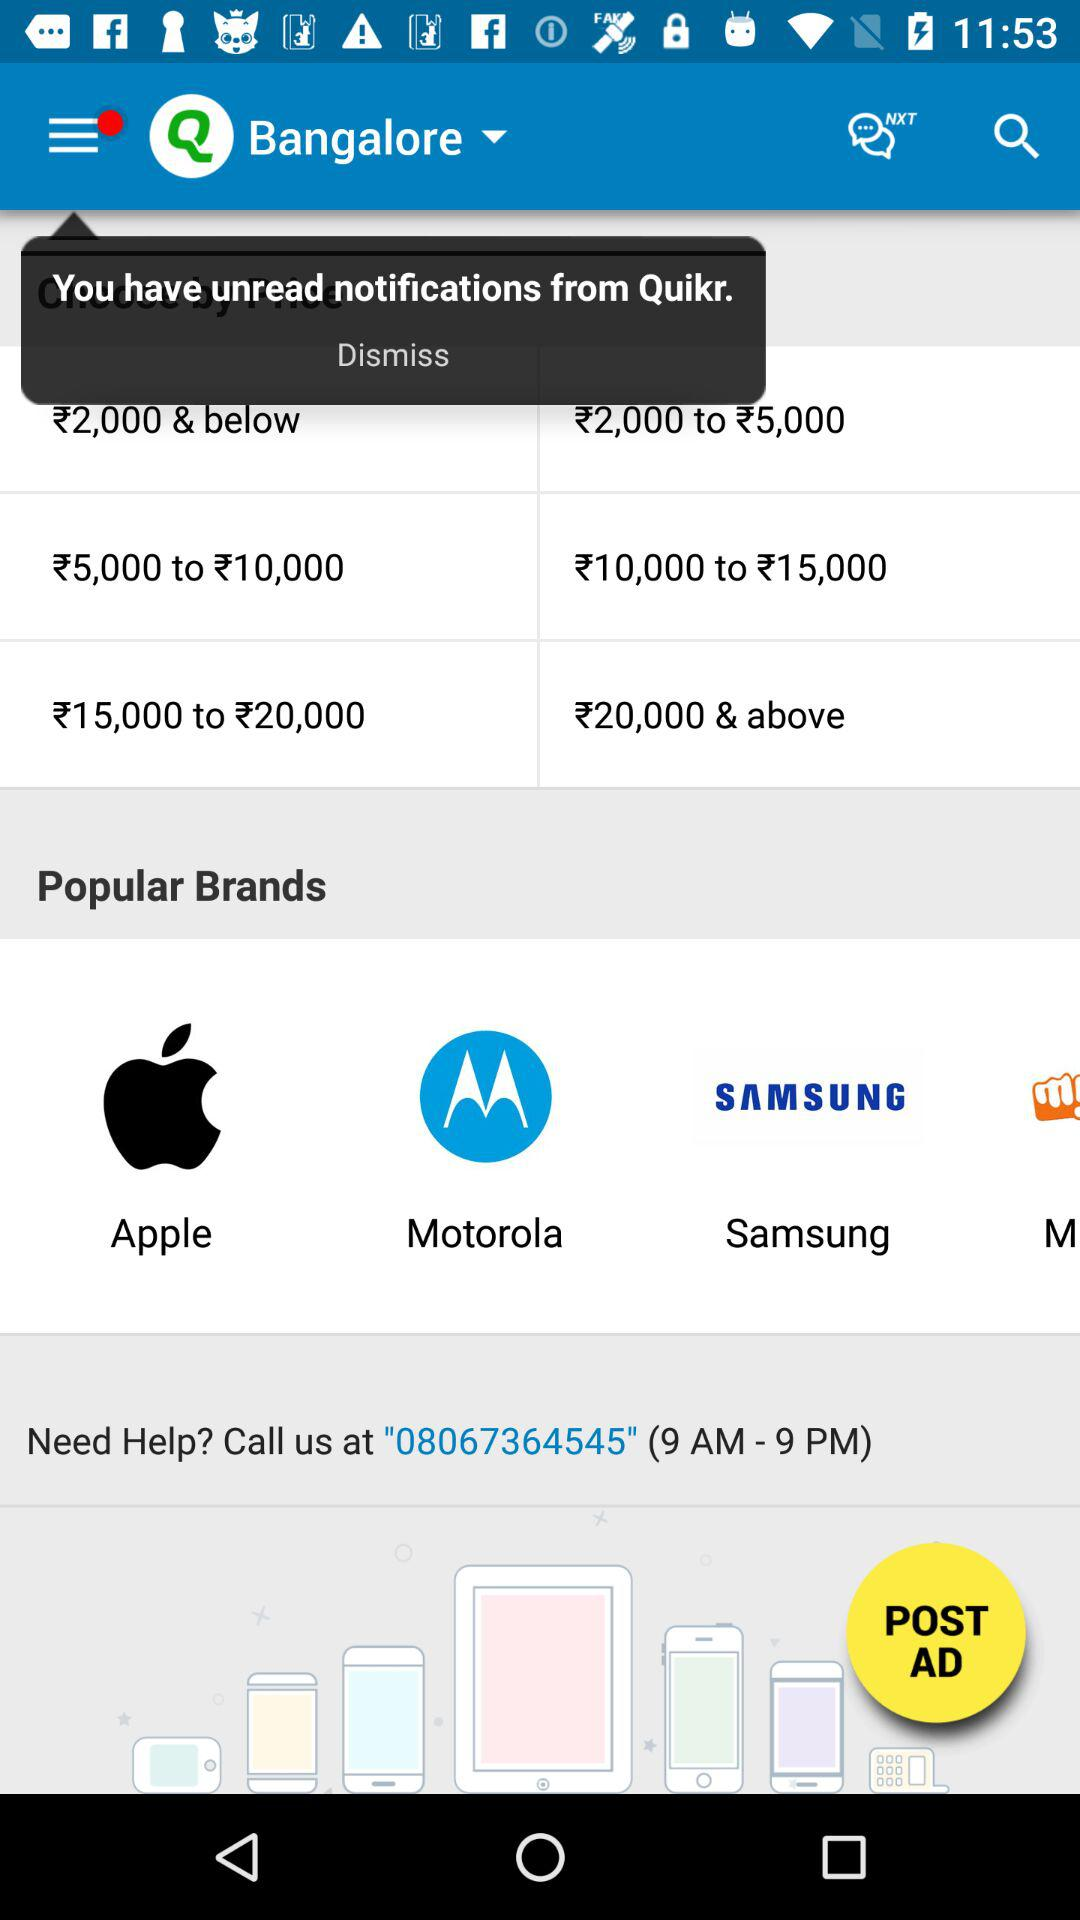How many brands are there on the screen?
Answer the question using a single word or phrase. 4 